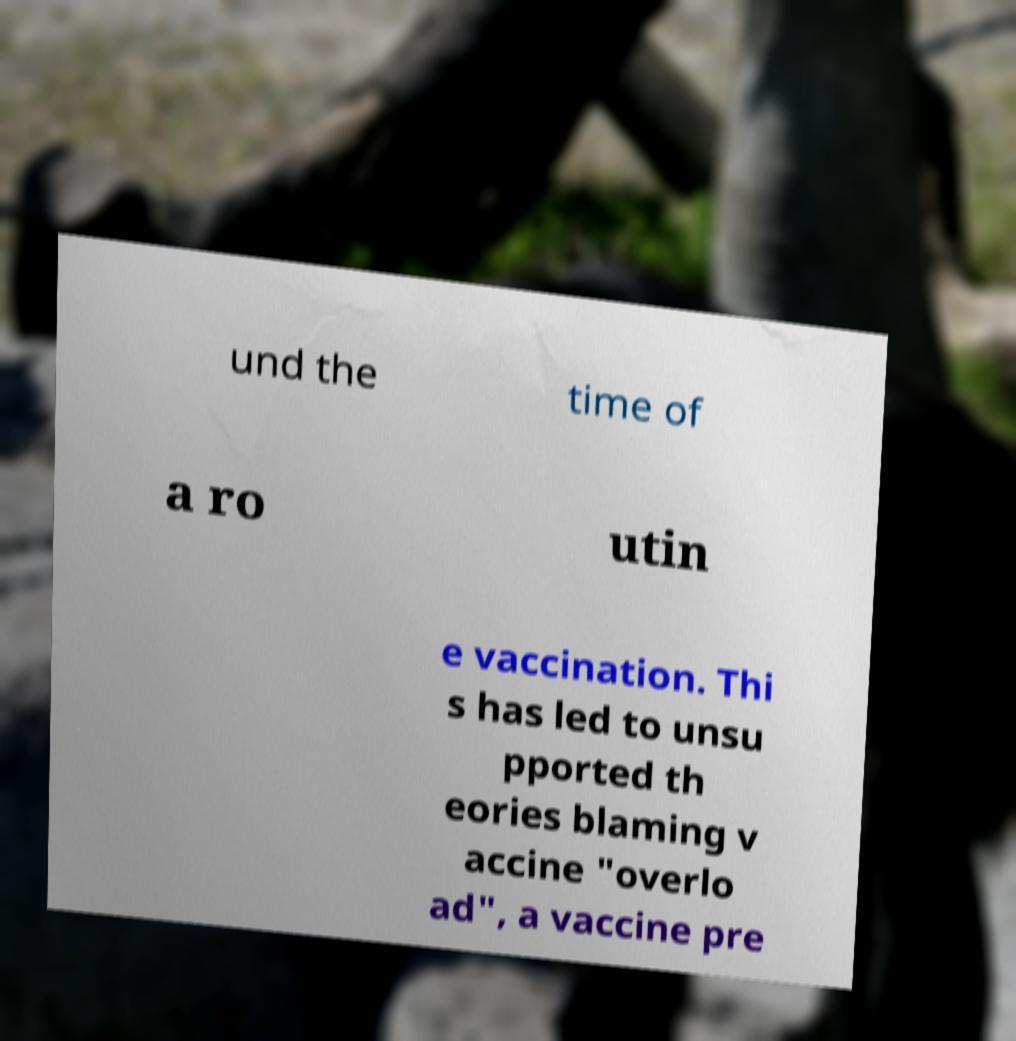Can you read and provide the text displayed in the image?This photo seems to have some interesting text. Can you extract and type it out for me? und the time of a ro utin e vaccination. Thi s has led to unsu pported th eories blaming v accine "overlo ad", a vaccine pre 